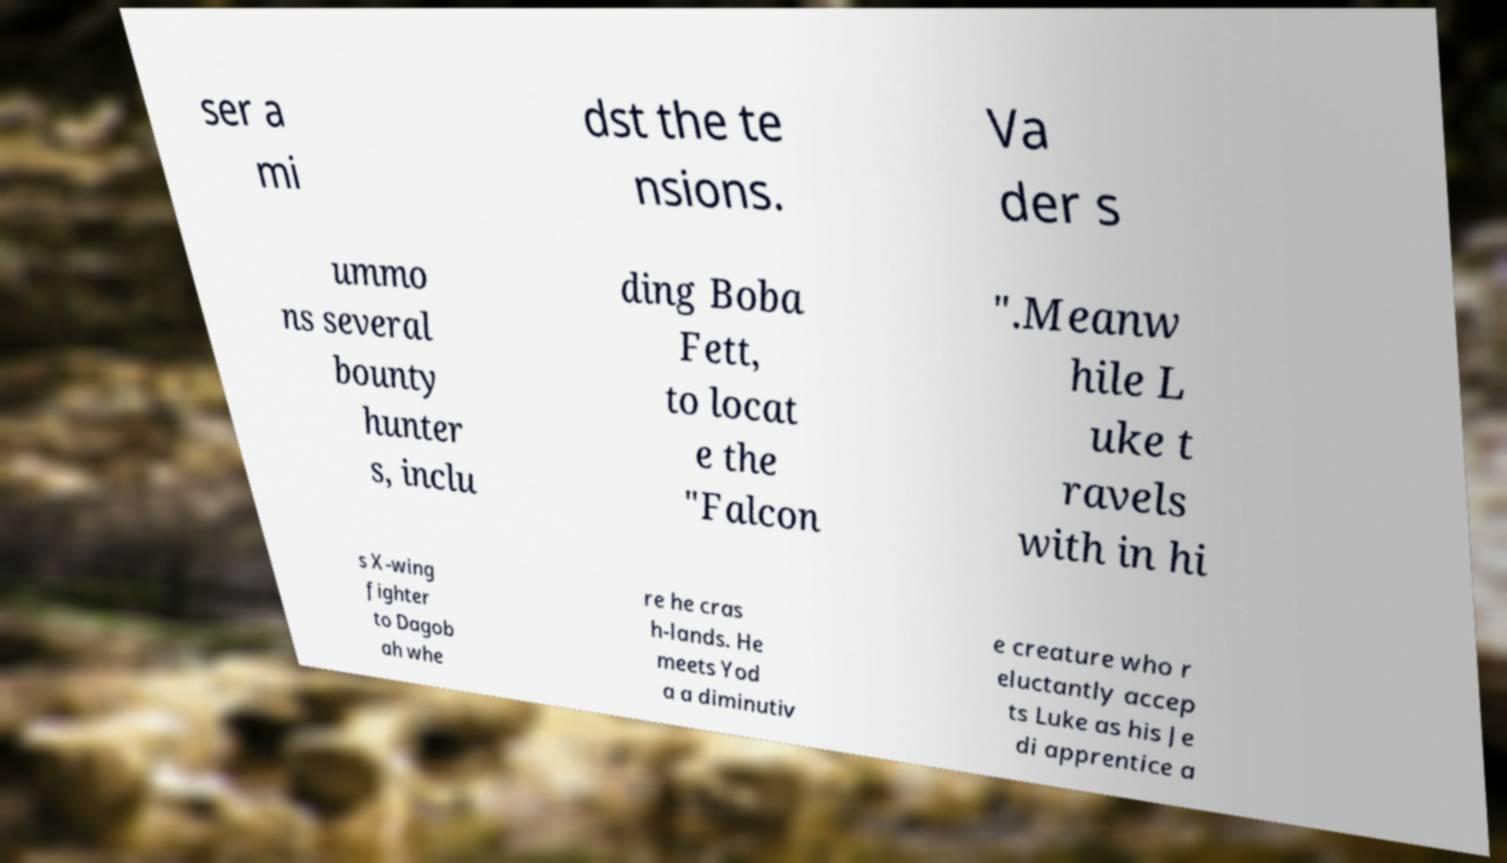I need the written content from this picture converted into text. Can you do that? ser a mi dst the te nsions. Va der s ummo ns several bounty hunter s, inclu ding Boba Fett, to locat e the "Falcon ".Meanw hile L uke t ravels with in hi s X-wing fighter to Dagob ah whe re he cras h-lands. He meets Yod a a diminutiv e creature who r eluctantly accep ts Luke as his Je di apprentice a 